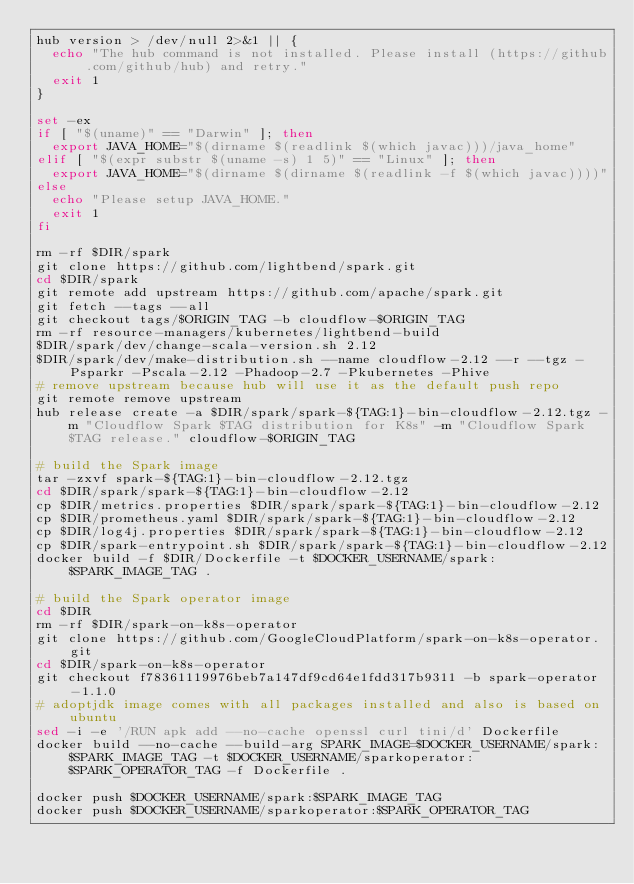<code> <loc_0><loc_0><loc_500><loc_500><_Bash_>hub version > /dev/null 2>&1 || {
  echo "The hub command is not installed. Please install (https://github.com/github/hub) and retry."
  exit 1
}

set -ex
if [ "$(uname)" == "Darwin" ]; then
  export JAVA_HOME="$(dirname $(readlink $(which javac)))/java_home"
elif [ "$(expr substr $(uname -s) 1 5)" == "Linux" ]; then
  export JAVA_HOME="$(dirname $(dirname $(readlink -f $(which javac))))"
else
  echo "Please setup JAVA_HOME."
  exit 1
fi

rm -rf $DIR/spark
git clone https://github.com/lightbend/spark.git
cd $DIR/spark
git remote add upstream https://github.com/apache/spark.git
git fetch --tags --all
git checkout tags/$ORIGIN_TAG -b cloudflow-$ORIGIN_TAG
rm -rf resource-managers/kubernetes/lightbend-build
$DIR/spark/dev/change-scala-version.sh 2.12
$DIR/spark/dev/make-distribution.sh --name cloudflow-2.12 --r --tgz -Psparkr -Pscala-2.12 -Phadoop-2.7 -Pkubernetes -Phive
# remove upstream because hub will use it as the default push repo
git remote remove upstream
hub release create -a $DIR/spark/spark-${TAG:1}-bin-cloudflow-2.12.tgz -m "Cloudflow Spark $TAG distribution for K8s" -m "Cloudflow Spark $TAG release." cloudflow-$ORIGIN_TAG

# build the Spark image
tar -zxvf spark-${TAG:1}-bin-cloudflow-2.12.tgz
cd $DIR/spark/spark-${TAG:1}-bin-cloudflow-2.12
cp $DIR/metrics.properties $DIR/spark/spark-${TAG:1}-bin-cloudflow-2.12
cp $DIR/prometheus.yaml $DIR/spark/spark-${TAG:1}-bin-cloudflow-2.12
cp $DIR/log4j.properties $DIR/spark/spark-${TAG:1}-bin-cloudflow-2.12
cp $DIR/spark-entrypoint.sh $DIR/spark/spark-${TAG:1}-bin-cloudflow-2.12
docker build -f $DIR/Dockerfile -t $DOCKER_USERNAME/spark:$SPARK_IMAGE_TAG .

# build the Spark operator image
cd $DIR
rm -rf $DIR/spark-on-k8s-operator
git clone https://github.com/GoogleCloudPlatform/spark-on-k8s-operator.git
cd $DIR/spark-on-k8s-operator
git checkout f78361119976beb7a147df9cd64e1fdd317b9311 -b spark-operator-1.1.0
# adoptjdk image comes with all packages installed and also is based on ubuntu
sed -i -e '/RUN apk add --no-cache openssl curl tini/d' Dockerfile
docker build --no-cache --build-arg SPARK_IMAGE=$DOCKER_USERNAME/spark:$SPARK_IMAGE_TAG -t $DOCKER_USERNAME/sparkoperator:$SPARK_OPERATOR_TAG -f Dockerfile .

docker push $DOCKER_USERNAME/spark:$SPARK_IMAGE_TAG
docker push $DOCKER_USERNAME/sparkoperator:$SPARK_OPERATOR_TAG
</code> 